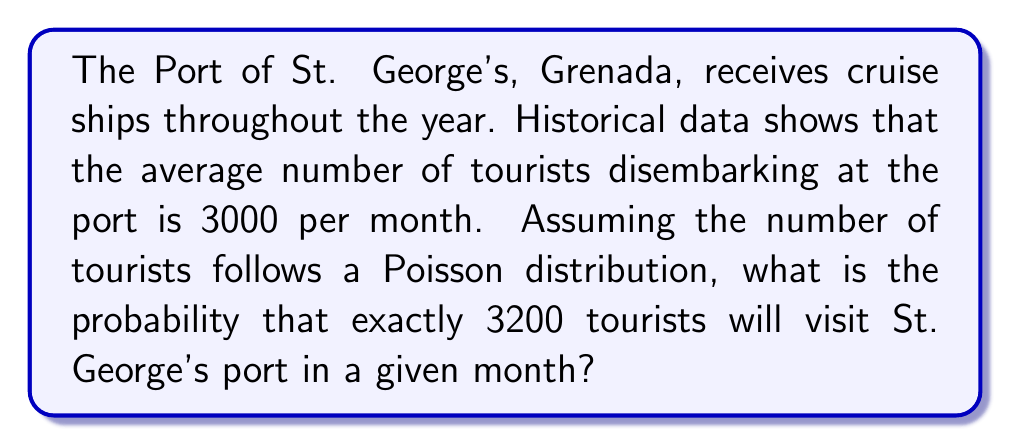What is the answer to this math problem? To solve this problem, we'll use the Poisson distribution formula:

$$P(X = k) = \frac{e^{-\lambda} \lambda^k}{k!}$$

Where:
$\lambda$ = average number of events (tourists) per interval (month)
$k$ = number of events we're calculating the probability for
$e$ = Euler's number (approximately 2.71828)

Given:
$\lambda = 3000$ (average tourists per month)
$k = 3200$ (number of tourists we're calculating the probability for)

Step 1: Plug the values into the Poisson distribution formula:

$$P(X = 3200) = \frac{e^{-3000} 3000^{3200}}{3200!}$$

Step 2: Calculate using a scientific calculator or computer software:

$$P(X = 3200) \approx 0.001079$$

Step 3: Convert to a percentage:

$$0.001079 \times 100\% \approx 0.1079\%$$

Therefore, the probability of exactly 3200 tourists visiting St. George's port in a given month is approximately 0.1079% or about 1 in 927 months.
Answer: 0.1079% 